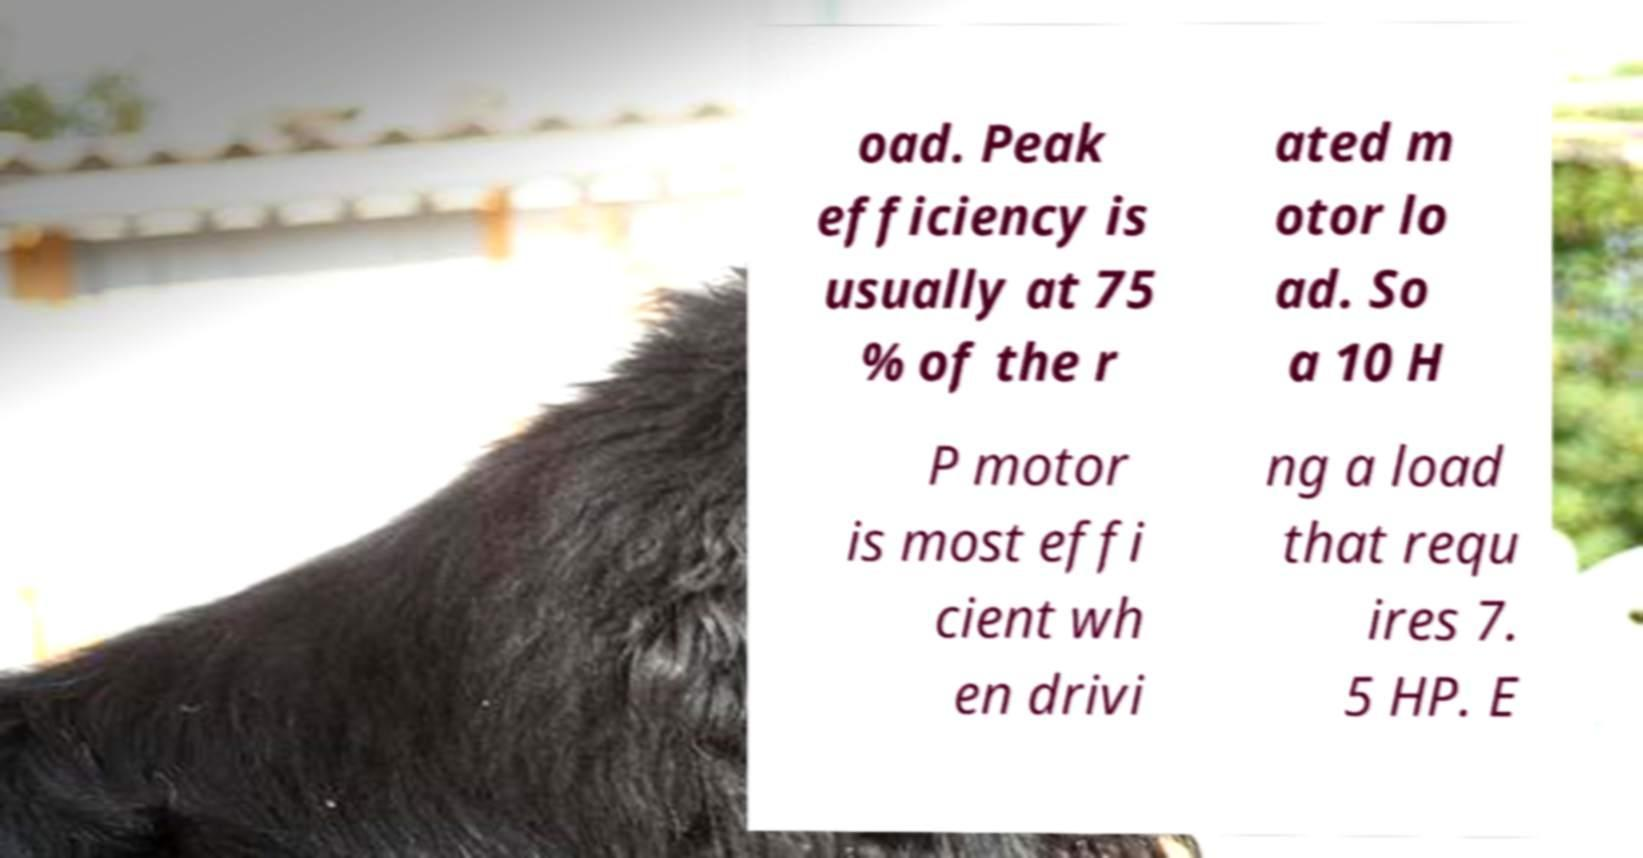Could you extract and type out the text from this image? oad. Peak efficiency is usually at 75 % of the r ated m otor lo ad. So a 10 H P motor is most effi cient wh en drivi ng a load that requ ires 7. 5 HP. E 